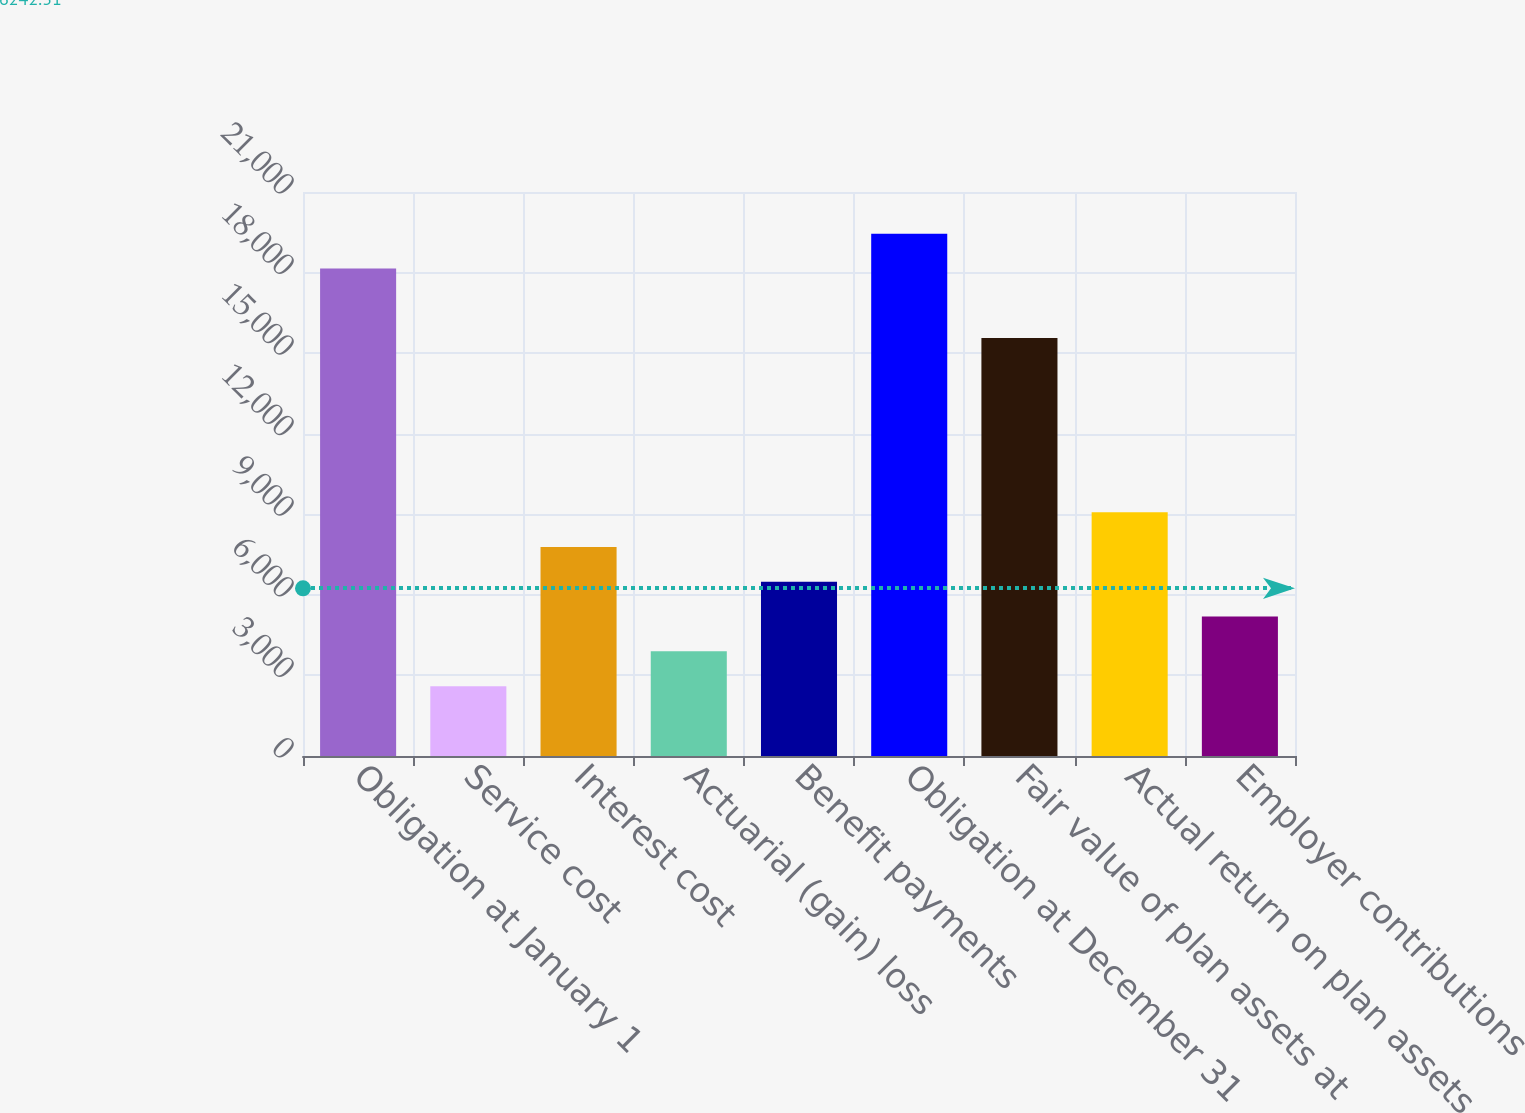Convert chart. <chart><loc_0><loc_0><loc_500><loc_500><bar_chart><fcel>Obligation at January 1<fcel>Service cost<fcel>Interest cost<fcel>Actuarial (gain) loss<fcel>Benefit payments<fcel>Obligation at December 31<fcel>Fair value of plan assets at<fcel>Actual return on plan assets<fcel>Employer contributions<nl><fcel>18152<fcel>2600<fcel>7784<fcel>3896<fcel>6488<fcel>19448<fcel>15560<fcel>9080<fcel>5192<nl></chart> 